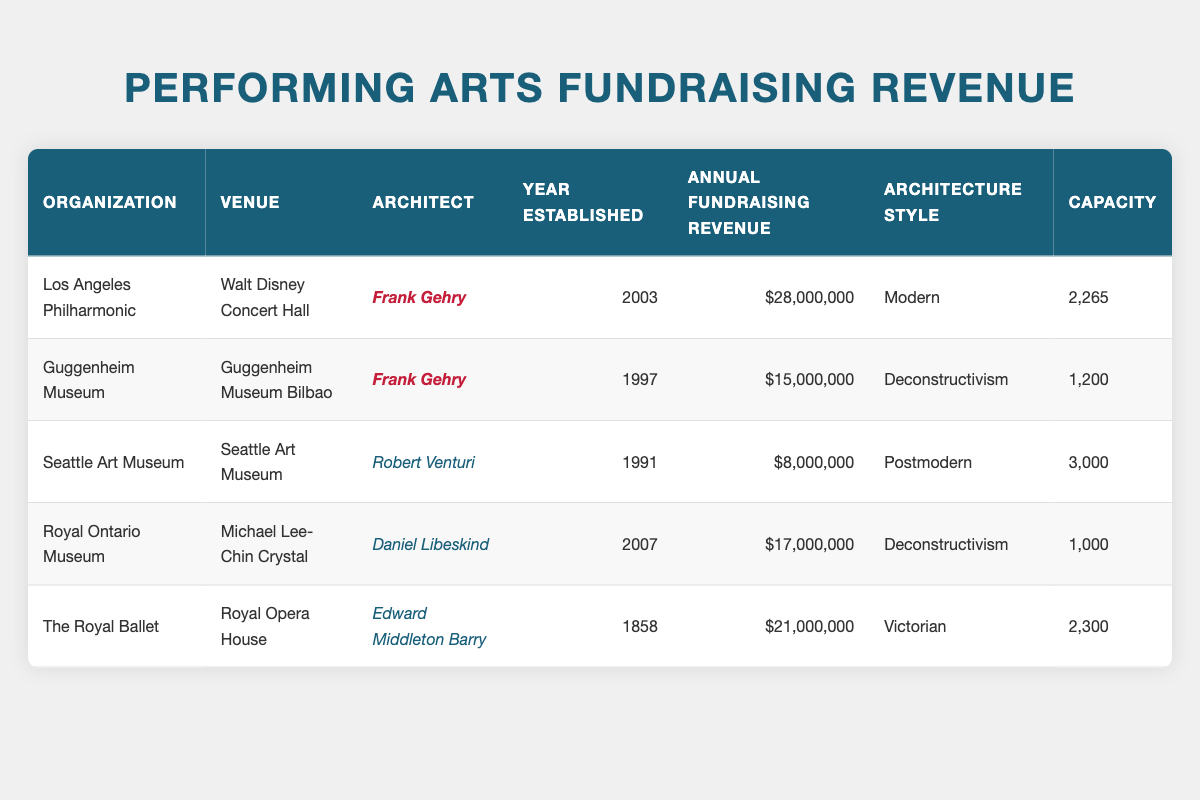What is the annual fundraising revenue for the Los Angeles Philharmonic? The table lists the Los Angeles Philharmonic in the first row, and the "Annual Fundraising Revenue" column indicates that it is $28,000,000.
Answer: 28,000,000 How many organizations have Frank Gehry as their architect? By checking the "Architect" column in the table, both the "Los Angeles Philharmonic" and the "Guggenheim Museum" have Frank Gehry listed as their architect, totaling to 2 organizations.
Answer: 2 What is the capacity of the Royal Opera House? The table shows that the "Royal Opera House" has a listed capacity of 2,300 in the "Capacity" column.
Answer: 2,300 What is the total annual fundraising revenue of all organizations listed? To find the total, add up the annual fundraising revenues: $28,000,000 + $15,000,000 + $8,000,000 + $17,000,000 + $21,000,000 = $89,000,000. Therefore, the total annual fundraising revenue is $89,000,000.
Answer: 89,000,000 Is the Guggenheim Museum the only organization established in the 1990s? The table shows that the Guggenheim Museum was established in 1997, and another entry, the Seattle Art Museum, was established in 1991. Since there are two organizations from the 1990s, the statement is false.
Answer: No What architectural style is associated with the greatest annual fundraising revenue, and what is that amount? The highest annual fundraising revenue in the table is $28,000,000 associated with the Modern architectural style of the Los Angeles Philharmonic, which is the only organization in that style with the highest revenue.
Answer: Modern; 28,000,000 How does the capacity of the Seattle Art Museum compare to the Royal Ontario Museum? The Seattle Art Museum has a capacity of 3,000, while the Royal Ontario Museum has a capacity of 1,000. Since 3,000 is greater than 1,000, the Seattle Art Museum has a greater capacity than the Royal Ontario Museum.
Answer: Seattle Art Museum has a greater capacity What is the average fundraising revenue of organizations designed by Frank Gehry? Calculate the average for Gehry's organizations: ($28,000,000 + $15,000,000) / 2 = $21,500,000. Therefore, the average fundraising revenue for organizations designed by Frank Gehry is $21,500,000.
Answer: 21,500,000 Which venue has the highest established year? The Royal Ontario Museum is established in 2007, which is the highest in the table. Check each year column to ascertain that no other venue has a higher number.
Answer: Michael Lee-Chin Crystal, 2007 